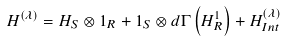<formula> <loc_0><loc_0><loc_500><loc_500>H ^ { \left ( \lambda \right ) } = H _ { S } \otimes 1 _ { R } + 1 _ { S } \otimes d \Gamma \left ( H _ { R } ^ { 1 } \right ) + H _ { I n t } ^ { \left ( \lambda \right ) }</formula> 